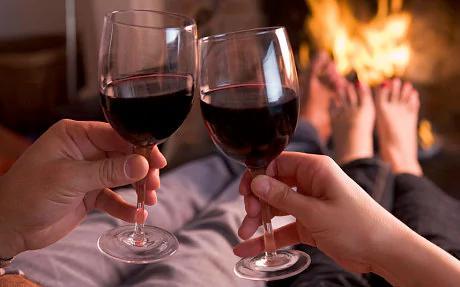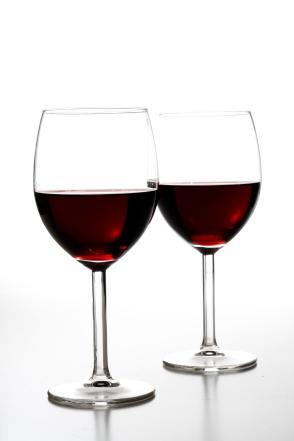The first image is the image on the left, the second image is the image on the right. Examine the images to the left and right. Is the description "A hearth fire is visible in the background behind two glasses of dark red wine." accurate? Answer yes or no. Yes. The first image is the image on the left, the second image is the image on the right. For the images displayed, is the sentence "A wine bottle is near two wine glasses in at least one of the images." factually correct? Answer yes or no. No. 